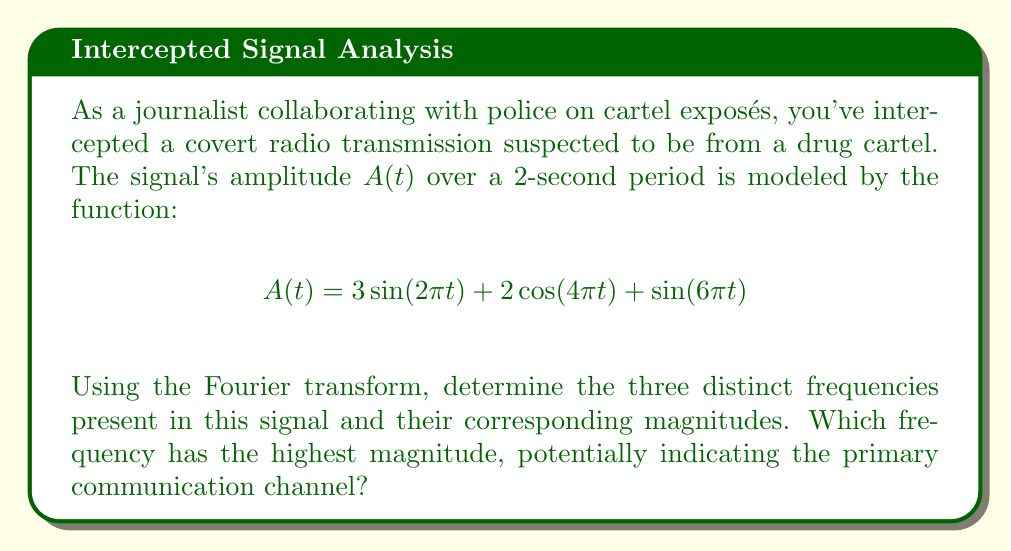Could you help me with this problem? To analyze the frequency spectrum of this signal, we'll use the Fourier transform. The given function is already expressed as a sum of sinusoids, which makes our analysis straightforward.

1) First, let's identify the frequencies:
   - $\sin(2\pi t)$ has a frequency of 1 Hz
   - $\cos(4\pi t)$ has a frequency of 2 Hz
   - $\sin(6\pi t)$ has a frequency of 3 Hz

2) Now, let's determine the magnitude for each frequency:
   - For 1 Hz: The coefficient is 3, so the magnitude is 3
   - For 2 Hz: The coefficient is 2, so the magnitude is 2
   - For 3 Hz: The coefficient is 1, so the magnitude is 1

3) To visualize this, we could represent the frequency spectrum as follows:

[asy]
size(200,150);
draw((0,0)--(4,0),arrow);
draw((0,0)--(0,4),arrow);
label("Frequency (Hz)",4,SW);
label("Magnitude",W,3);
draw((1,0)--(1,3),blue+1);
draw((2,0)--(2,2),red+1);
draw((3,0)--(3,1),green+1);
label("1",1,-0.5);
label("2",2,-0.5);
label("3",3,-0.5);
label("3",1,3,N);
label("2",2,2,N);
label("1",3,1,N);
[/asy]

4) The frequency with the highest magnitude is 1 Hz, with a magnitude of 3. This suggests that the primary communication channel might be operating at this frequency.
Answer: The three distinct frequencies are 1 Hz, 2 Hz, and 3 Hz, with corresponding magnitudes of 3, 2, and 1 respectively. The frequency with the highest magnitude is 1 Hz, potentially indicating the primary communication channel. 